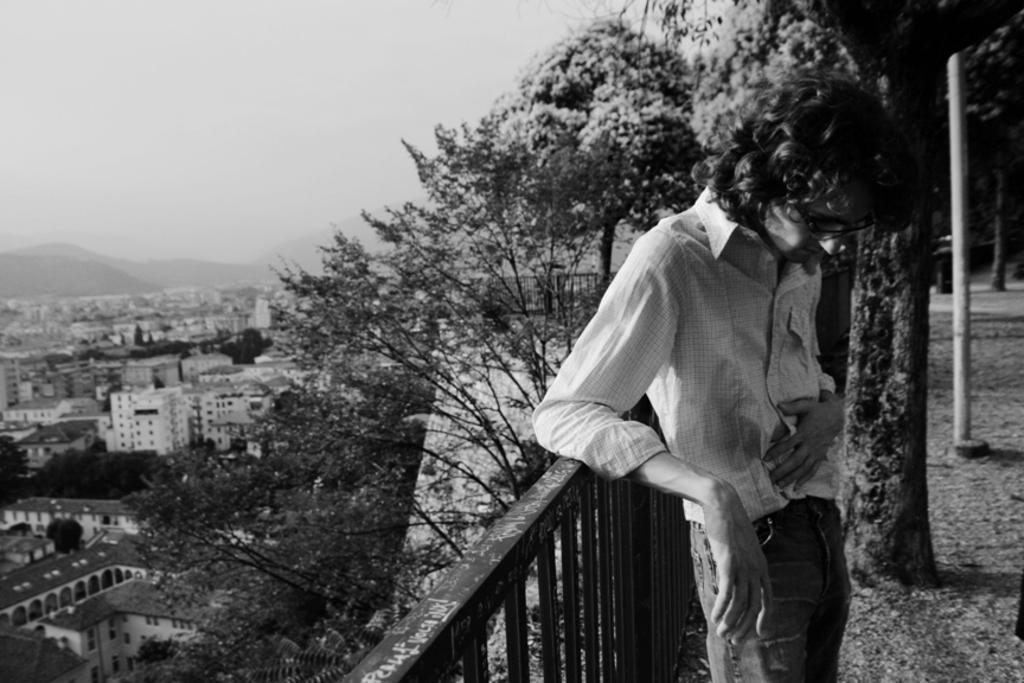In one or two sentences, can you explain what this image depicts? In this image I can see on the right side there is a man standing, in the middle it is the railing. On the left side there are trees and buildings, at the top it is the sky. 